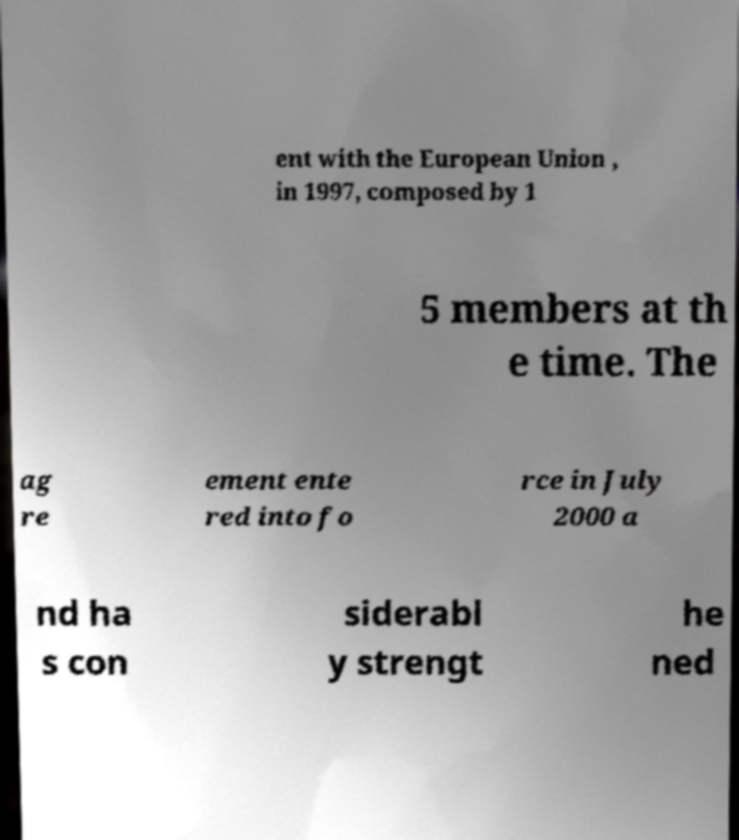Can you accurately transcribe the text from the provided image for me? ent with the European Union , in 1997, composed by 1 5 members at th e time. The ag re ement ente red into fo rce in July 2000 a nd ha s con siderabl y strengt he ned 